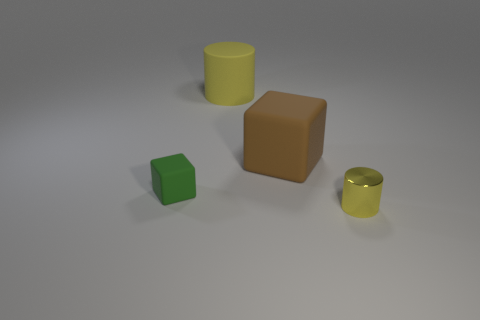Is there any indication of what material these objects could be made of? The image depicts the objects with different finishes, which suggest they could be made from various materials. The matte finish on the cubes implies they could be made of plastic or wood, while the glossy finish of the cylinders suggests they might be made of a polished metal or ceramics. 